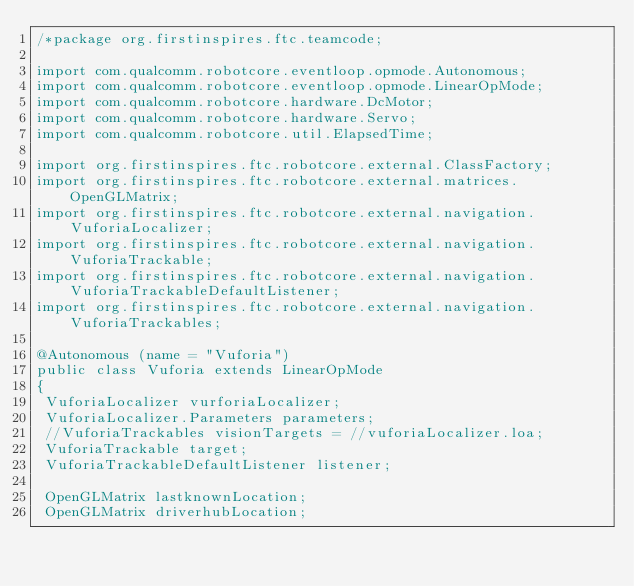Convert code to text. <code><loc_0><loc_0><loc_500><loc_500><_Java_>/*package org.firstinspires.ftc.teamcode;

import com.qualcomm.robotcore.eventloop.opmode.Autonomous;
import com.qualcomm.robotcore.eventloop.opmode.LinearOpMode;
import com.qualcomm.robotcore.hardware.DcMotor;
import com.qualcomm.robotcore.hardware.Servo;
import com.qualcomm.robotcore.util.ElapsedTime;

import org.firstinspires.ftc.robotcore.external.ClassFactory;
import org.firstinspires.ftc.robotcore.external.matrices.OpenGLMatrix;
import org.firstinspires.ftc.robotcore.external.navigation.VuforiaLocalizer;
import org.firstinspires.ftc.robotcore.external.navigation.VuforiaTrackable;
import org.firstinspires.ftc.robotcore.external.navigation.VuforiaTrackableDefaultListener;
import org.firstinspires.ftc.robotcore.external.navigation.VuforiaTrackables;

@Autonomous (name = "Vuforia")
public class Vuforia extends LinearOpMode
{
 VuforiaLocalizer vurforiaLocalizer;
 VuforiaLocalizer.Parameters parameters;
 //VuforiaTrackables visionTargets = //vuforiaLocalizer.loa;
 VuforiaTrackable target;
 VuforiaTrackableDefaultListener listener;

 OpenGLMatrix lastknownLocation;
 OpenGLMatrix driverhubLocation;
</code> 